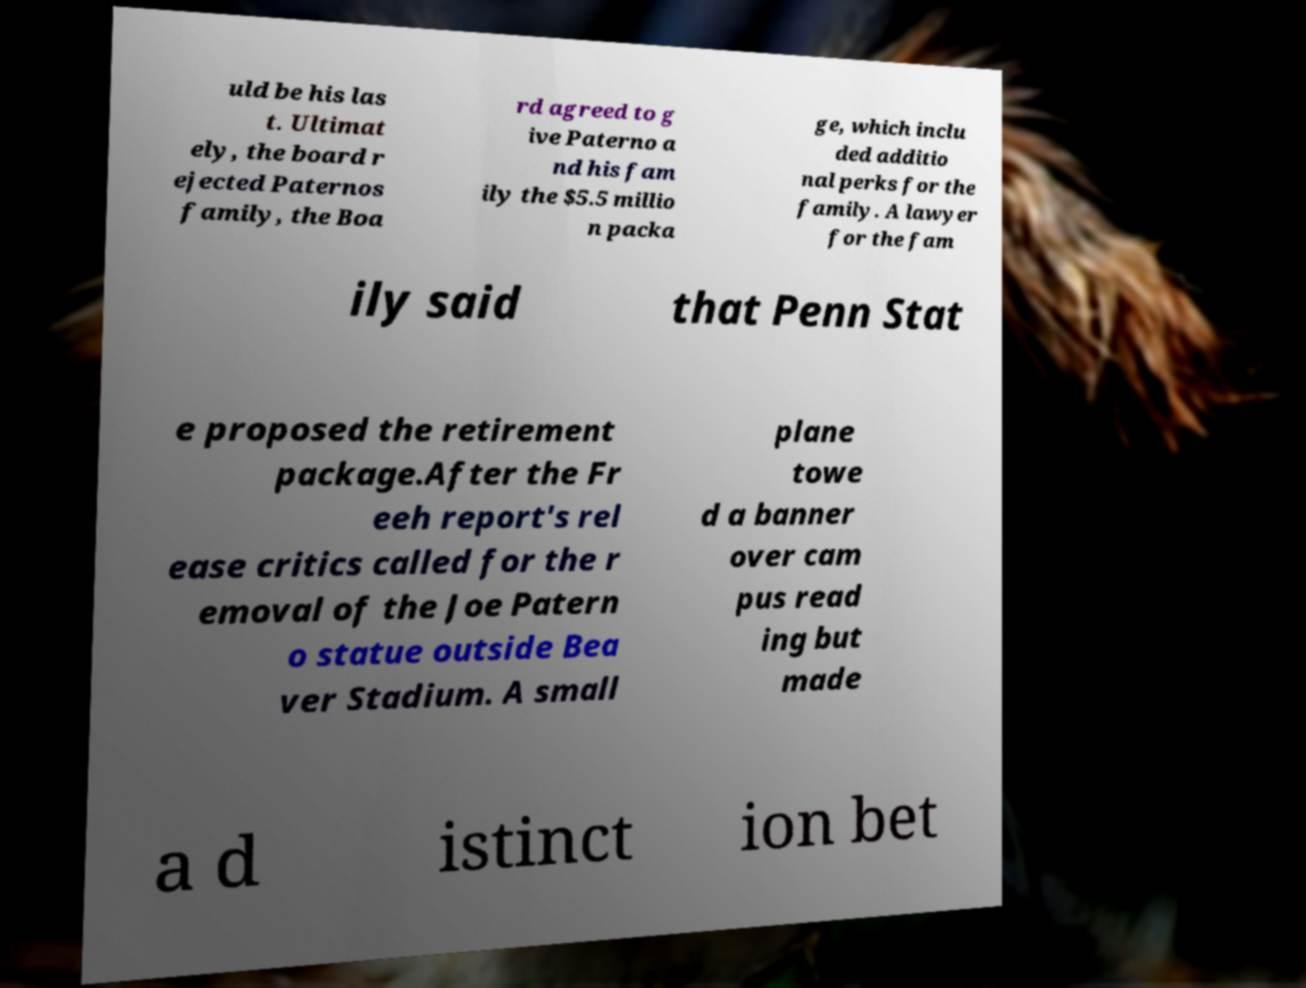Could you assist in decoding the text presented in this image and type it out clearly? uld be his las t. Ultimat ely, the board r ejected Paternos family, the Boa rd agreed to g ive Paterno a nd his fam ily the $5.5 millio n packa ge, which inclu ded additio nal perks for the family. A lawyer for the fam ily said that Penn Stat e proposed the retirement package.After the Fr eeh report's rel ease critics called for the r emoval of the Joe Patern o statue outside Bea ver Stadium. A small plane towe d a banner over cam pus read ing but made a d istinct ion bet 